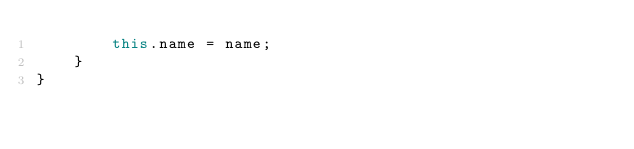<code> <loc_0><loc_0><loc_500><loc_500><_TypeScript_>        this.name = name;
    }
}</code> 